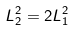Convert formula to latex. <formula><loc_0><loc_0><loc_500><loc_500>L _ { 2 } ^ { 2 } = 2 L _ { 1 } ^ { 2 }</formula> 